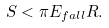Convert formula to latex. <formula><loc_0><loc_0><loc_500><loc_500>S < \pi E _ { f a l l } R .</formula> 